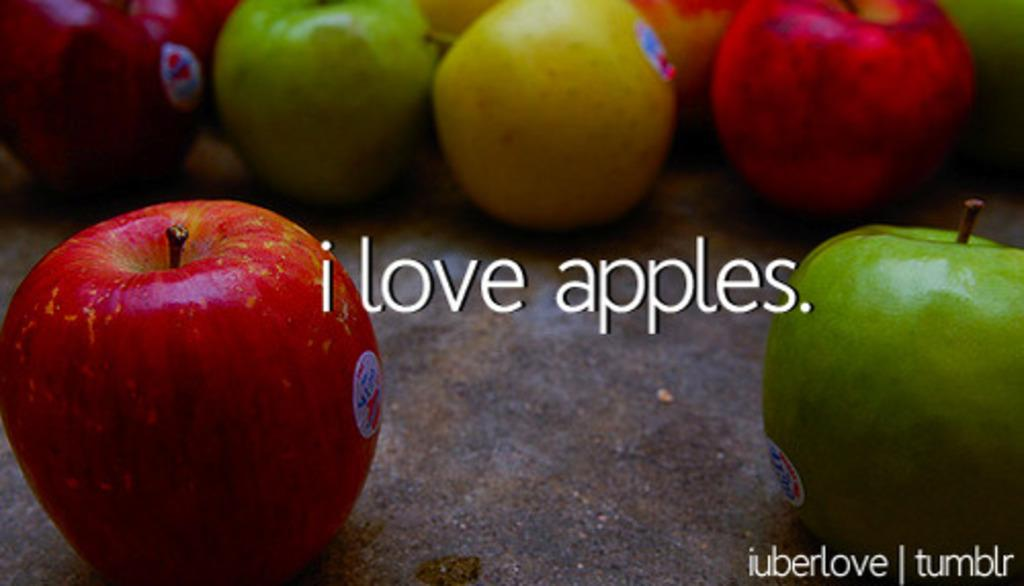What is located in the foreground of the image? There are apples in the foreground of the image. Where are the apples placed? The apples are on a surface. What message is conveyed in the middle of the image? The text in the middle of the image says "I LOVE APPLES." What type of car is parked next to the apples in the image? There is no car present in the image; it only features apples and text. What value does the image place on hope? The image does not mention or depict anything related to hope, as it focuses on apples and the message "I LOVE APPLES." 